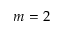Convert formula to latex. <formula><loc_0><loc_0><loc_500><loc_500>m = 2</formula> 